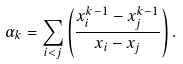<formula> <loc_0><loc_0><loc_500><loc_500>\alpha _ { k } = \sum _ { i < j } \left ( \frac { x _ { i } ^ { k - 1 } - x _ { j } ^ { k - 1 } } { x _ { i } - x _ { j } } \right ) .</formula> 